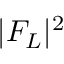<formula> <loc_0><loc_0><loc_500><loc_500>| F _ { L } | ^ { 2 }</formula> 